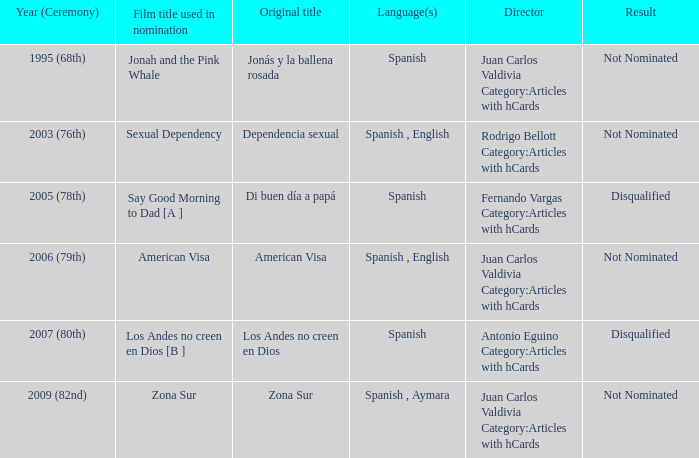What was Zona Sur's result after being considered for nomination? Not Nominated. 